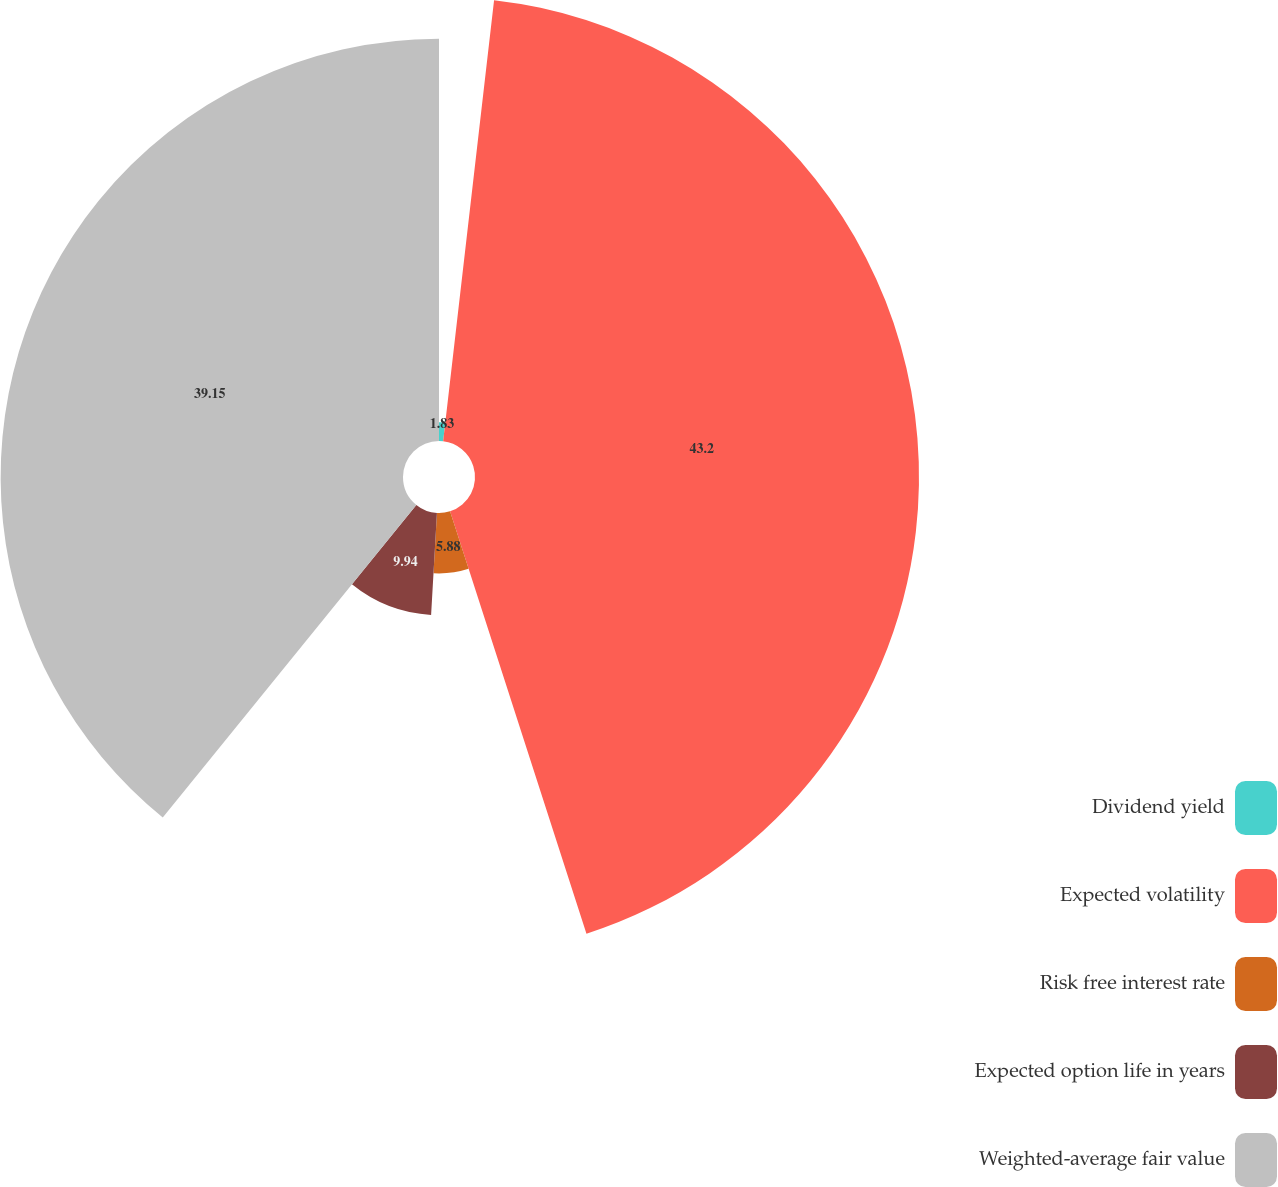Convert chart. <chart><loc_0><loc_0><loc_500><loc_500><pie_chart><fcel>Dividend yield<fcel>Expected volatility<fcel>Risk free interest rate<fcel>Expected option life in years<fcel>Weighted-average fair value<nl><fcel>1.83%<fcel>43.2%<fcel>5.88%<fcel>9.94%<fcel>39.15%<nl></chart> 